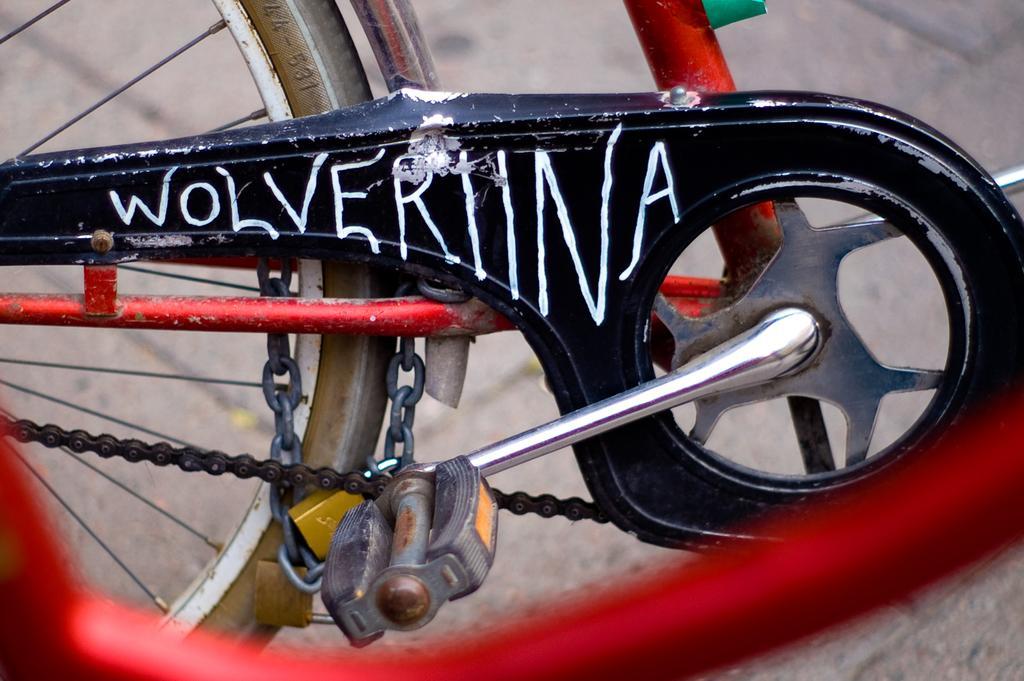Could you give a brief overview of what you see in this image? In this image I can see a bicycle which is in red and black color. I can see chain,lock,bicycle pedal and a wheel. 